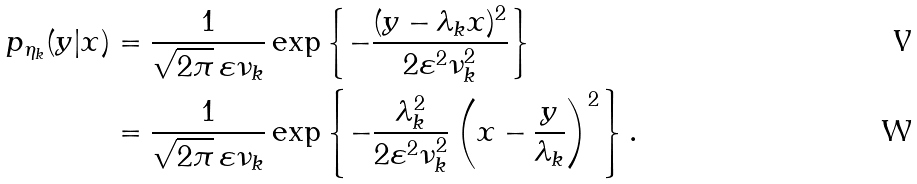<formula> <loc_0><loc_0><loc_500><loc_500>p _ { \eta _ { k } } ( y | x ) & = \frac { 1 } { \sqrt { 2 \pi } \, \varepsilon \nu _ { k } } \exp \left \{ - \frac { ( y - \lambda _ { k } x ) ^ { 2 } } { 2 \varepsilon ^ { 2 } \nu _ { k } ^ { 2 } } \right \} \\ & = \frac { 1 } { \sqrt { 2 \pi } \, \varepsilon \nu _ { k } } \exp \left \{ - \frac { \lambda _ { k } ^ { 2 } } { 2 \varepsilon ^ { 2 } \nu _ { k } ^ { 2 } } \left ( x - \frac { y } { \lambda _ { k } } \right ) ^ { 2 } \right \} .</formula> 